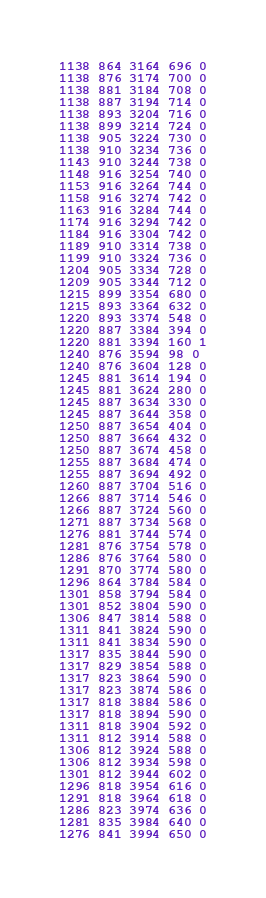Convert code to text. <code><loc_0><loc_0><loc_500><loc_500><_SML_>1138 864 3164 696 0
1138 876 3174 700 0
1138 881 3184 708 0
1138 887 3194 714 0
1138 893 3204 716 0
1138 899 3214 724 0
1138 905 3224 730 0
1138 910 3234 736 0
1143 910 3244 738 0
1148 916 3254 740 0
1153 916 3264 744 0
1158 916 3274 742 0
1163 916 3284 744 0
1174 916 3294 742 0
1184 916 3304 742 0
1189 910 3314 738 0
1199 910 3324 736 0
1204 905 3334 728 0
1209 905 3344 712 0
1215 899 3354 680 0
1215 893 3364 632 0
1220 893 3374 548 0
1220 887 3384 394 0
1220 881 3394 160 1
1240 876 3594 98 0
1240 876 3604 128 0
1245 881 3614 194 0
1245 881 3624 280 0
1245 887 3634 330 0
1245 887 3644 358 0
1250 887 3654 404 0
1250 887 3664 432 0
1250 887 3674 458 0
1255 887 3684 474 0
1255 887 3694 492 0
1260 887 3704 516 0
1266 887 3714 546 0
1266 887 3724 560 0
1271 887 3734 568 0
1276 881 3744 574 0
1281 876 3754 578 0
1286 876 3764 580 0
1291 870 3774 580 0
1296 864 3784 584 0
1301 858 3794 584 0
1301 852 3804 590 0
1306 847 3814 588 0
1311 841 3824 590 0
1311 841 3834 590 0
1317 835 3844 590 0
1317 829 3854 588 0
1317 823 3864 590 0
1317 823 3874 586 0
1317 818 3884 586 0
1317 818 3894 590 0
1311 818 3904 592 0
1311 812 3914 588 0
1306 812 3924 588 0
1306 812 3934 598 0
1301 812 3944 602 0
1296 818 3954 616 0
1291 818 3964 618 0
1286 823 3974 636 0
1281 835 3984 640 0
1276 841 3994 650 0</code> 